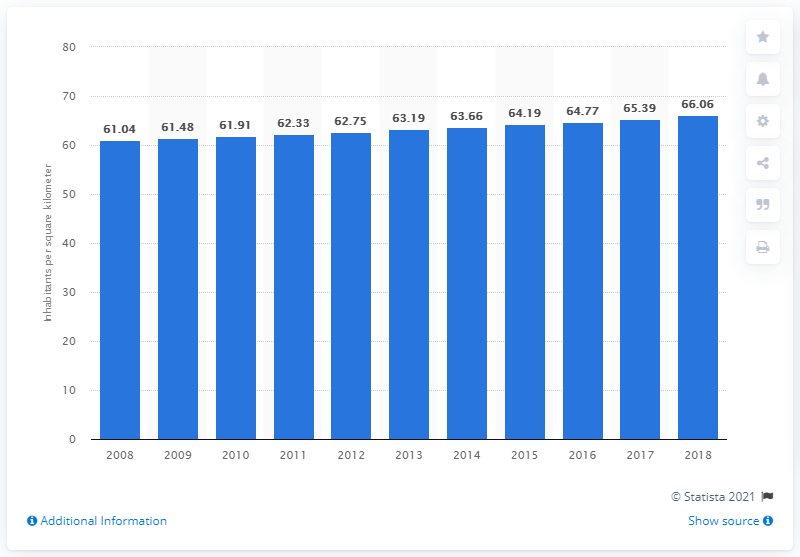Highlight a few significant elements in this photo. In 2018, the population density of Swaziland was approximately 66.06 people per square kilometer. 